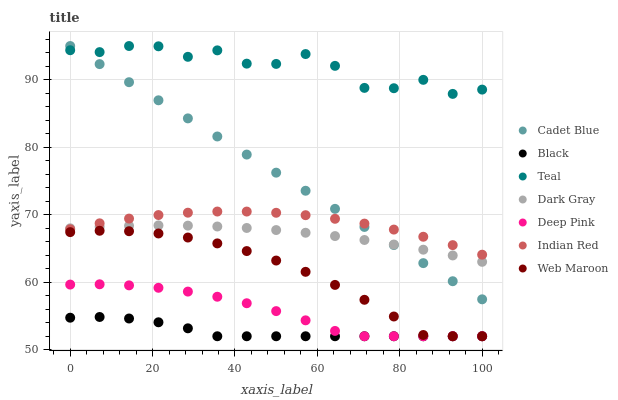Does Black have the minimum area under the curve?
Answer yes or no. Yes. Does Teal have the maximum area under the curve?
Answer yes or no. Yes. Does Web Maroon have the minimum area under the curve?
Answer yes or no. No. Does Web Maroon have the maximum area under the curve?
Answer yes or no. No. Is Cadet Blue the smoothest?
Answer yes or no. Yes. Is Teal the roughest?
Answer yes or no. Yes. Is Web Maroon the smoothest?
Answer yes or no. No. Is Web Maroon the roughest?
Answer yes or no. No. Does Web Maroon have the lowest value?
Answer yes or no. Yes. Does Teal have the lowest value?
Answer yes or no. No. Does Teal have the highest value?
Answer yes or no. Yes. Does Web Maroon have the highest value?
Answer yes or no. No. Is Deep Pink less than Dark Gray?
Answer yes or no. Yes. Is Indian Red greater than Black?
Answer yes or no. Yes. Does Indian Red intersect Dark Gray?
Answer yes or no. Yes. Is Indian Red less than Dark Gray?
Answer yes or no. No. Is Indian Red greater than Dark Gray?
Answer yes or no. No. Does Deep Pink intersect Dark Gray?
Answer yes or no. No. 